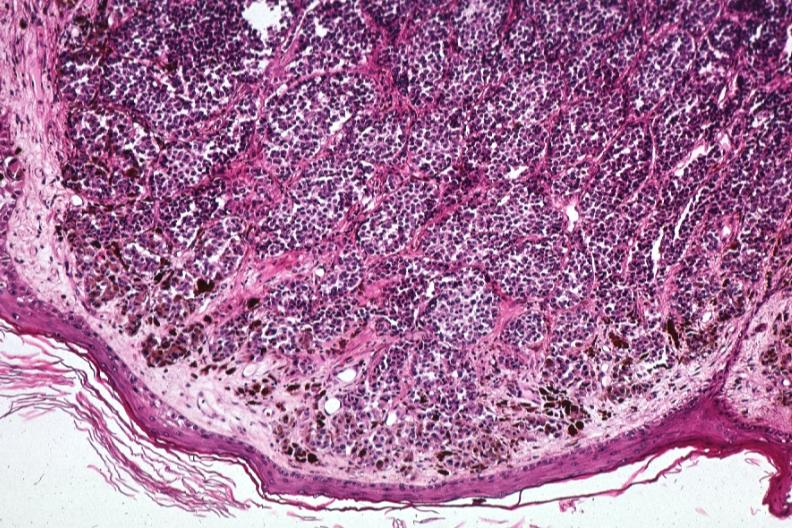what are same lesion?
Answer the question using a single word or phrase. 1 